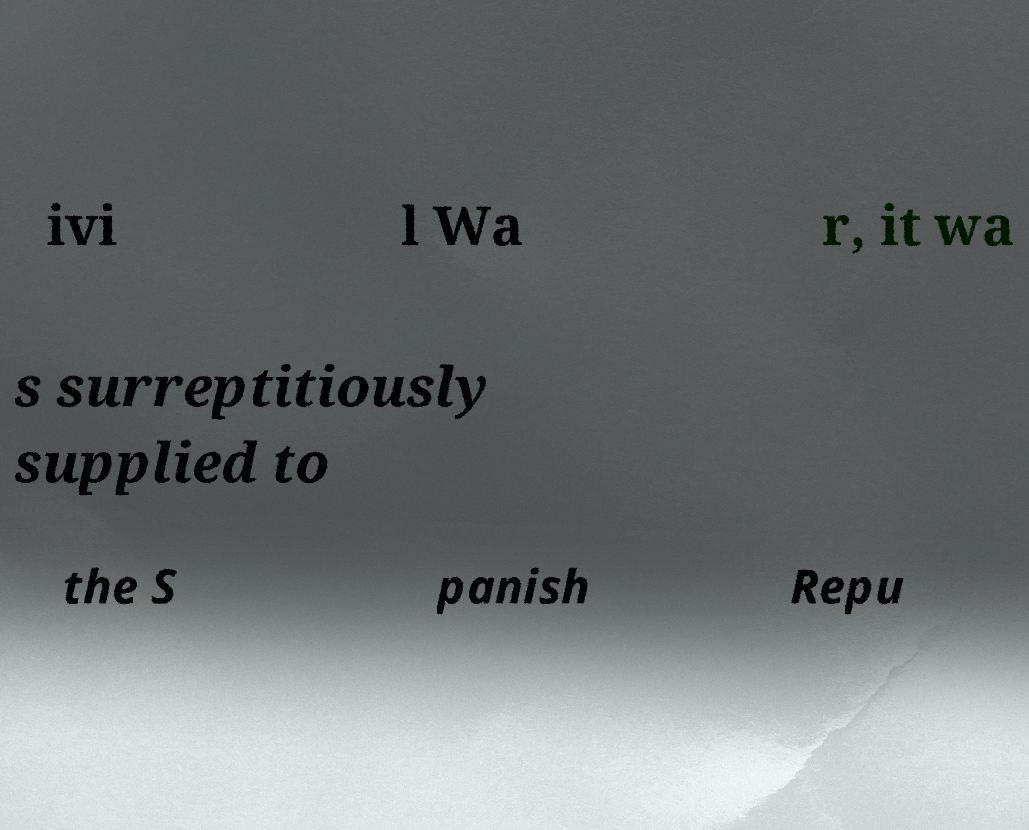Can you read and provide the text displayed in the image?This photo seems to have some interesting text. Can you extract and type it out for me? ivi l Wa r, it wa s surreptitiously supplied to the S panish Repu 